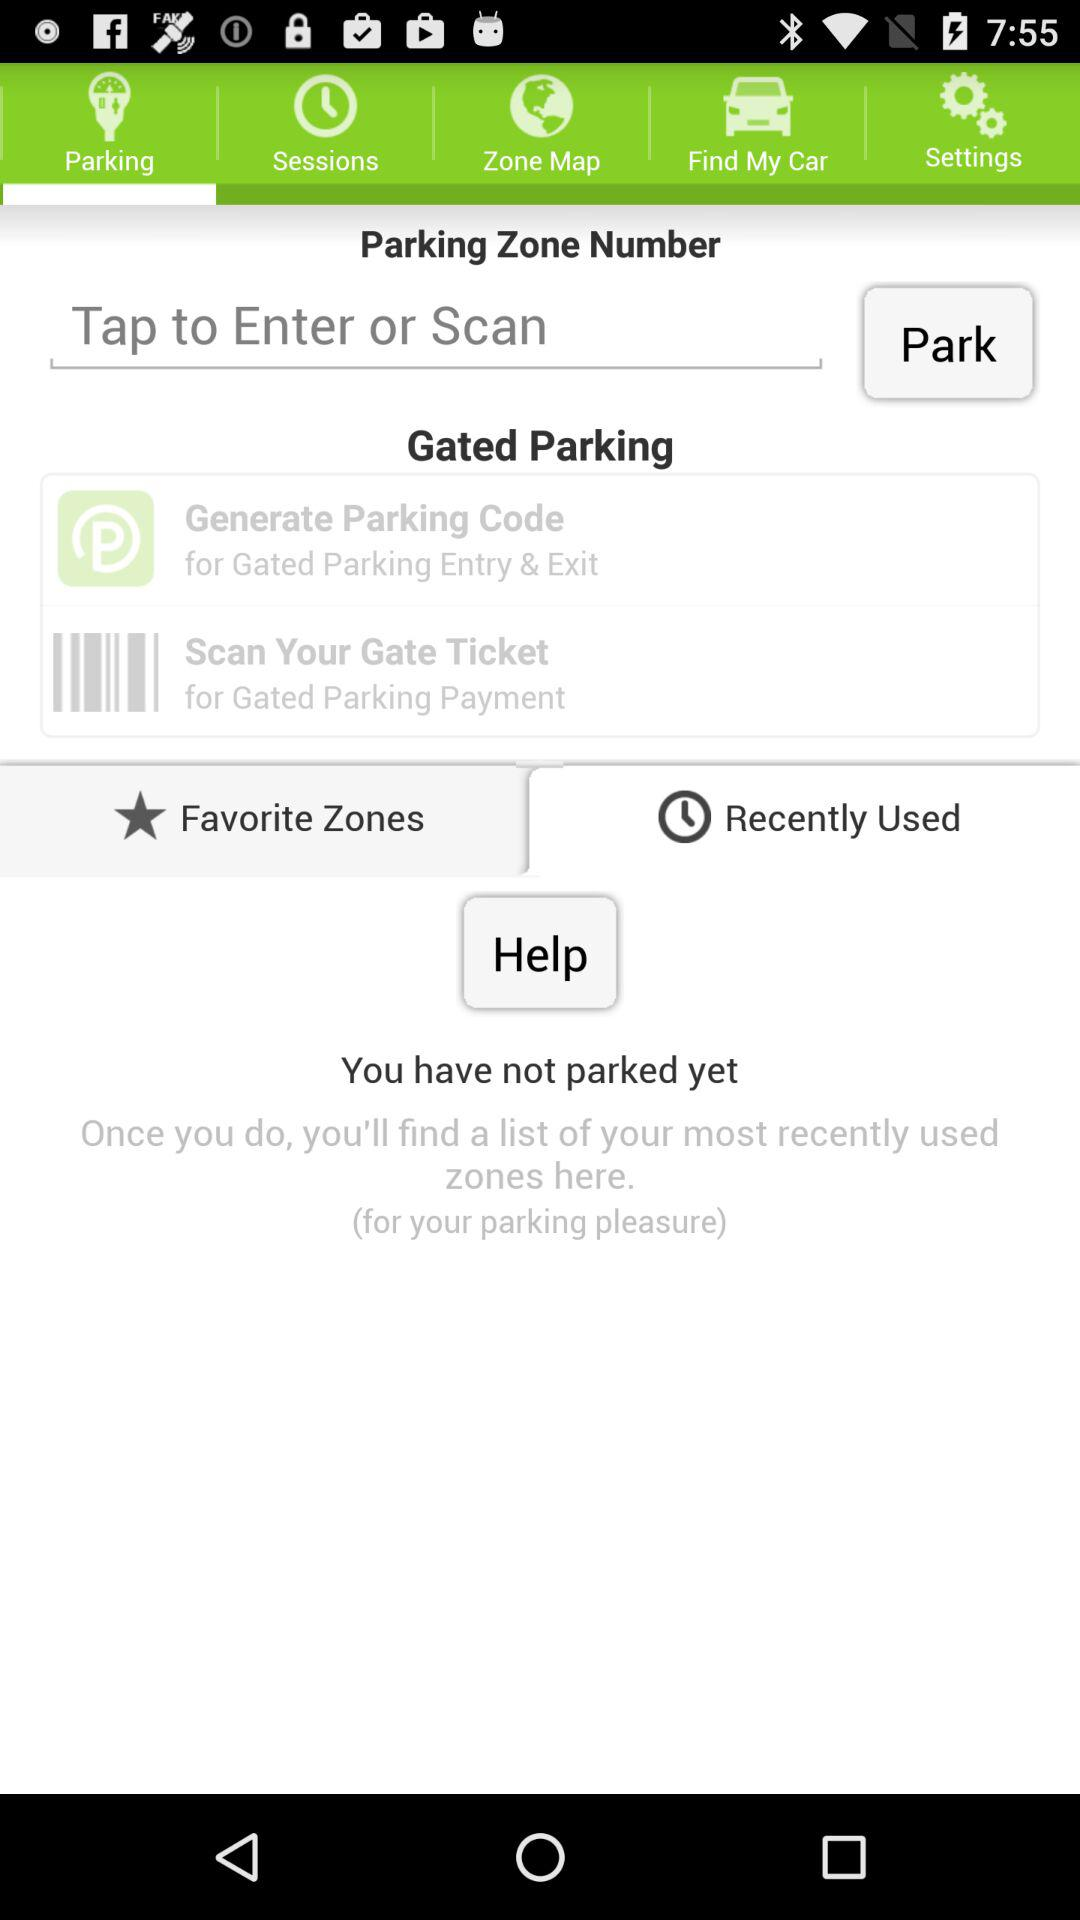How many options are there to pay for gated parking?
Answer the question using a single word or phrase. 2 